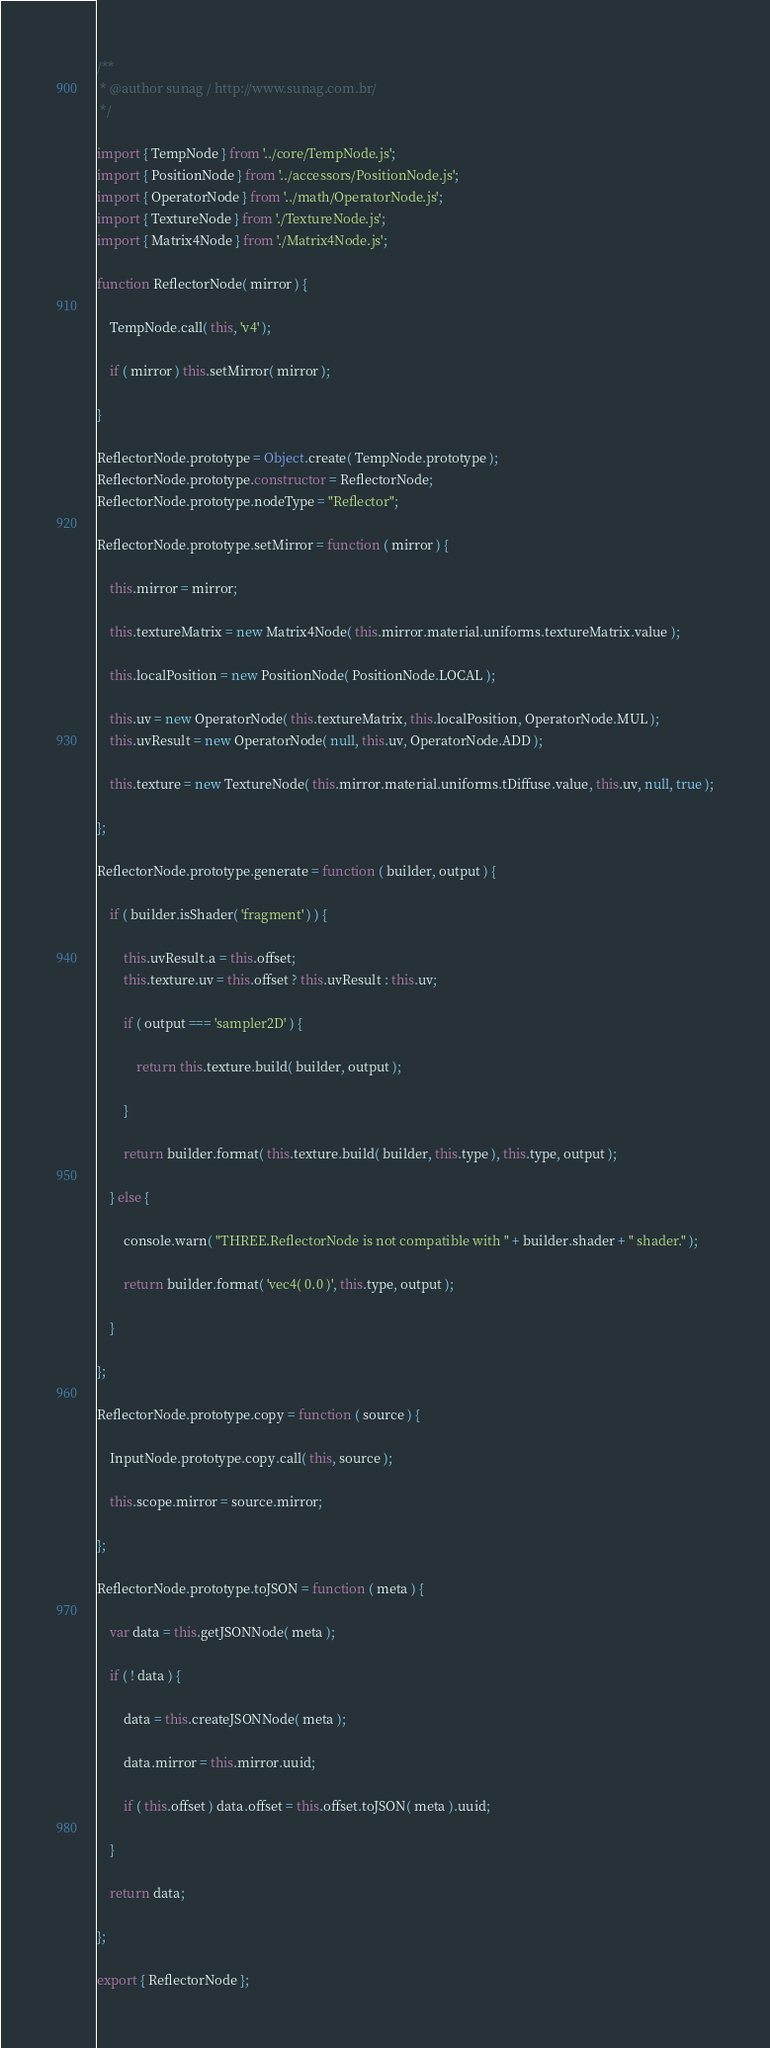<code> <loc_0><loc_0><loc_500><loc_500><_JavaScript_>/**
 * @author sunag / http://www.sunag.com.br/
 */

import { TempNode } from '../core/TempNode.js';
import { PositionNode } from '../accessors/PositionNode.js';
import { OperatorNode } from '../math/OperatorNode.js';
import { TextureNode } from './TextureNode.js';
import { Matrix4Node } from './Matrix4Node.js';

function ReflectorNode( mirror ) {

	TempNode.call( this, 'v4' );

	if ( mirror ) this.setMirror( mirror );

}

ReflectorNode.prototype = Object.create( TempNode.prototype );
ReflectorNode.prototype.constructor = ReflectorNode;
ReflectorNode.prototype.nodeType = "Reflector";

ReflectorNode.prototype.setMirror = function ( mirror ) {

	this.mirror = mirror;

	this.textureMatrix = new Matrix4Node( this.mirror.material.uniforms.textureMatrix.value );

	this.localPosition = new PositionNode( PositionNode.LOCAL );

	this.uv = new OperatorNode( this.textureMatrix, this.localPosition, OperatorNode.MUL );
	this.uvResult = new OperatorNode( null, this.uv, OperatorNode.ADD );

	this.texture = new TextureNode( this.mirror.material.uniforms.tDiffuse.value, this.uv, null, true );

};

ReflectorNode.prototype.generate = function ( builder, output ) {

	if ( builder.isShader( 'fragment' ) ) {

		this.uvResult.a = this.offset;
		this.texture.uv = this.offset ? this.uvResult : this.uv;

		if ( output === 'sampler2D' ) {

			return this.texture.build( builder, output );

		}

		return builder.format( this.texture.build( builder, this.type ), this.type, output );

	} else {

		console.warn( "THREE.ReflectorNode is not compatible with " + builder.shader + " shader." );

		return builder.format( 'vec4( 0.0 )', this.type, output );

	}

};

ReflectorNode.prototype.copy = function ( source ) {

	InputNode.prototype.copy.call( this, source );

	this.scope.mirror = source.mirror;

};

ReflectorNode.prototype.toJSON = function ( meta ) {

	var data = this.getJSONNode( meta );

	if ( ! data ) {

		data = this.createJSONNode( meta );

		data.mirror = this.mirror.uuid;

		if ( this.offset ) data.offset = this.offset.toJSON( meta ).uuid;

	}

	return data;

};

export { ReflectorNode };
</code> 